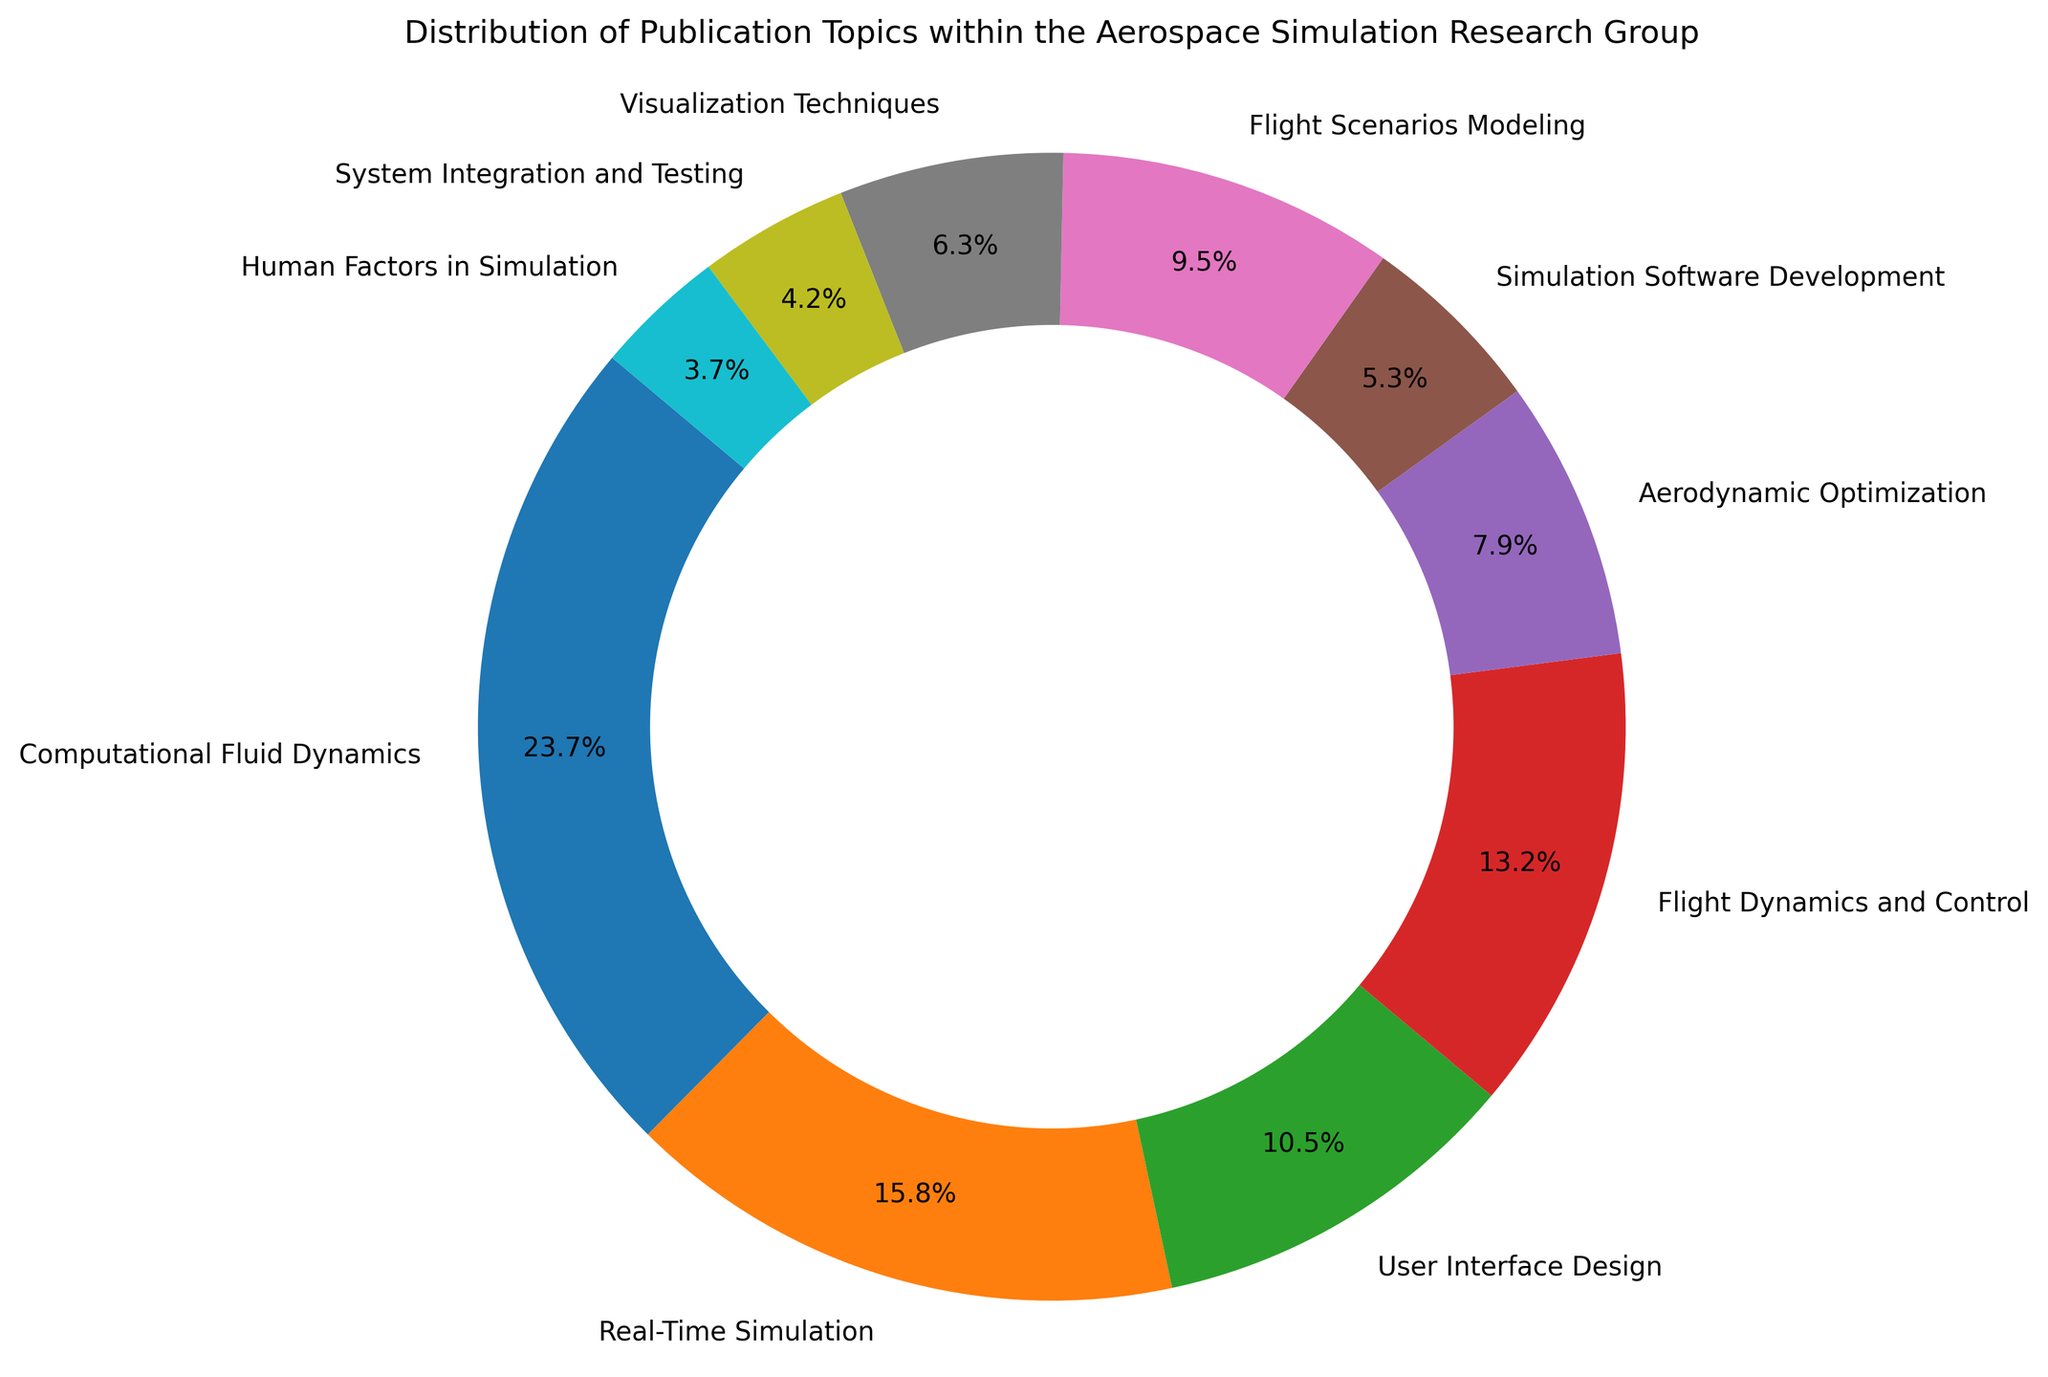What percentage of publications are related to Computational Fluid Dynamics (CFD)? First, identify the number of publications related to CFD, which is 45. Next, add up all publication counts: 45 + 30 + 20 + 25 + 15 + 10 + 18 + 12 + 8 + 7 = 190. Finally, divide the number of CFD publications by the total count and multiply by 100 to get the percentage: (45 / 190) * 100 ≈ 23.7%
Answer: 23.7% Is User Interface Design more popular than Flight Dynamics and Control? Find the publication count for User Interface Design (20) and for Flight Dynamics and Control (25). Compare them; since 20 is less than 25, Flight Dynamics and Control is more popular.
Answer: No Which two topics have the smallest number of publications? Sort the publication counts in ascending order: 7, 8, 10, 12, 15, 18, 20, 25, 30, 45. The two smallest numbers are for System Integration and Testing (8) and Human Factors in Simulation (7).
Answer: System Integration and Testing, Human Factors in Simulation What is the combined count of publications in Flight Scenarios Modeling and Visualization Techniques? Find the publication counts for Flight Scenarios Modeling (18) and Visualization Techniques (12). Add them together: 18 + 12 = 30.
Answer: 30 How does Real-Time Simulation compare to Aerodynamic Optimization in terms of publication counts? Find the publication counts for Real-Time Simulation (30) and Aerodynamic Optimization (15). Since 30 is greater than 15, Real-Time Simulation has more publications.
Answer: Real-Time Simulation has more What portion of the publications are dedicated to topics other than Computational Fluid Dynamics and Real-Time Simulation? First, sum the publication counts for all topics except CFD and Real-Time Simulation: 20 + 25 + 15 + 10 + 18 + 12 + 8 + 7 = 115. From the total of 190 publications, the portion dedicated to other topics is 115 / 190 ≈ 60.5%.
Answer: 60.5% Which topic has the third highest number of publications? Sort the topics by publication count: 45 (CFD), 30 (Real-Time Simulation), 25 (Flight Dynamics and Control). Thus, Flight Dynamics and Control is the third highest.
Answer: Flight Dynamics and Control What is the difference in publication counts between the most and least popular topics? The most popular topic, CFD, has 45 publications. The least popular topic, Human Factors in Simulation, has 7 publications. The difference is 45 - 7 = 38.
Answer: 38 